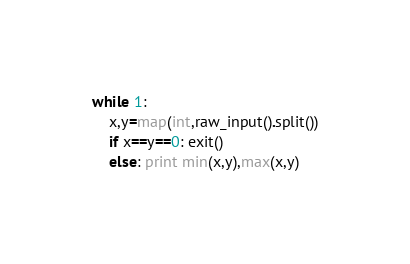Convert code to text. <code><loc_0><loc_0><loc_500><loc_500><_Python_>while 1:
    x,y=map(int,raw_input().split())
    if x==y==0: exit()
    else: print min(x,y),max(x,y)</code> 